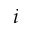Convert formula to latex. <formula><loc_0><loc_0><loc_500><loc_500>i</formula> 